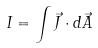Convert formula to latex. <formula><loc_0><loc_0><loc_500><loc_500>I = \int \vec { J } \cdot d \vec { A }</formula> 